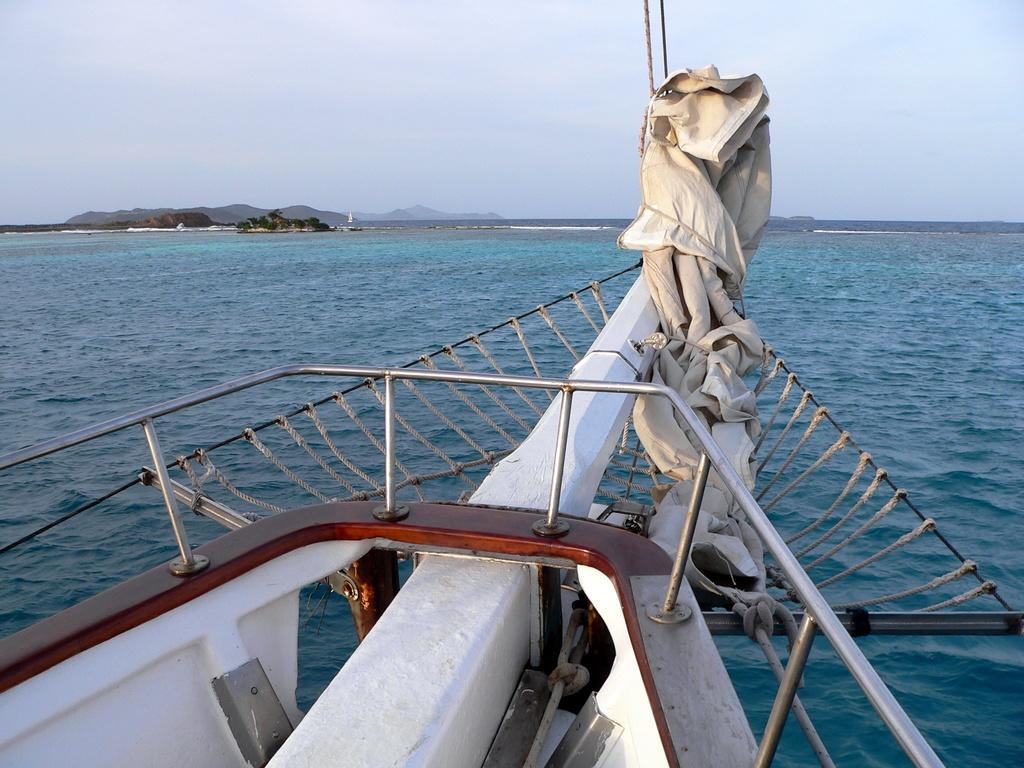Please provide a concise description of this image. In this image, we can see a part of a ship. Here we can see rods, ropes and sheet. In the background, we can see the water, trees, hills and sky. 